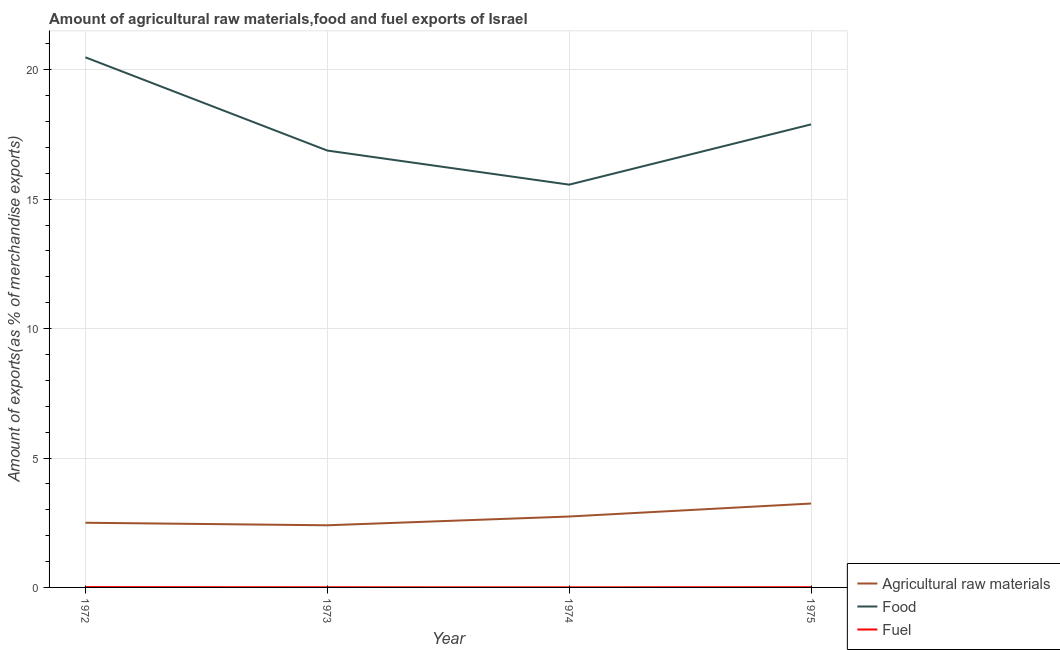Does the line corresponding to percentage of fuel exports intersect with the line corresponding to percentage of raw materials exports?
Offer a very short reply. No. Is the number of lines equal to the number of legend labels?
Your response must be concise. Yes. What is the percentage of fuel exports in 1973?
Ensure brevity in your answer.  0.01. Across all years, what is the maximum percentage of fuel exports?
Give a very brief answer. 0.01. Across all years, what is the minimum percentage of fuel exports?
Keep it short and to the point. 0. In which year was the percentage of fuel exports maximum?
Make the answer very short. 1972. What is the total percentage of food exports in the graph?
Your answer should be compact. 70.81. What is the difference between the percentage of fuel exports in 1972 and that in 1973?
Make the answer very short. 0.01. What is the difference between the percentage of fuel exports in 1974 and the percentage of food exports in 1972?
Ensure brevity in your answer.  -20.48. What is the average percentage of fuel exports per year?
Your answer should be very brief. 0.01. In the year 1973, what is the difference between the percentage of raw materials exports and percentage of fuel exports?
Offer a terse response. 2.39. In how many years, is the percentage of food exports greater than 5 %?
Your response must be concise. 4. What is the ratio of the percentage of fuel exports in 1972 to that in 1973?
Provide a short and direct response. 2.1. What is the difference between the highest and the second highest percentage of fuel exports?
Ensure brevity in your answer.  0. What is the difference between the highest and the lowest percentage of food exports?
Keep it short and to the point. 4.92. Is the percentage of fuel exports strictly greater than the percentage of raw materials exports over the years?
Provide a short and direct response. No. How many lines are there?
Make the answer very short. 3. How many years are there in the graph?
Make the answer very short. 4. What is the difference between two consecutive major ticks on the Y-axis?
Your answer should be very brief. 5. Are the values on the major ticks of Y-axis written in scientific E-notation?
Ensure brevity in your answer.  No. Does the graph contain grids?
Make the answer very short. Yes. How are the legend labels stacked?
Your answer should be very brief. Vertical. What is the title of the graph?
Your answer should be compact. Amount of agricultural raw materials,food and fuel exports of Israel. What is the label or title of the X-axis?
Your answer should be compact. Year. What is the label or title of the Y-axis?
Your response must be concise. Amount of exports(as % of merchandise exports). What is the Amount of exports(as % of merchandise exports) of Agricultural raw materials in 1972?
Your answer should be compact. 2.5. What is the Amount of exports(as % of merchandise exports) in Food in 1972?
Provide a succinct answer. 20.48. What is the Amount of exports(as % of merchandise exports) of Fuel in 1972?
Give a very brief answer. 0.01. What is the Amount of exports(as % of merchandise exports) of Agricultural raw materials in 1973?
Offer a very short reply. 2.4. What is the Amount of exports(as % of merchandise exports) of Food in 1973?
Your answer should be very brief. 16.88. What is the Amount of exports(as % of merchandise exports) in Fuel in 1973?
Your answer should be very brief. 0.01. What is the Amount of exports(as % of merchandise exports) of Agricultural raw materials in 1974?
Your response must be concise. 2.74. What is the Amount of exports(as % of merchandise exports) in Food in 1974?
Make the answer very short. 15.56. What is the Amount of exports(as % of merchandise exports) of Fuel in 1974?
Provide a succinct answer. 0. What is the Amount of exports(as % of merchandise exports) in Agricultural raw materials in 1975?
Your answer should be compact. 3.24. What is the Amount of exports(as % of merchandise exports) in Food in 1975?
Provide a short and direct response. 17.89. What is the Amount of exports(as % of merchandise exports) in Fuel in 1975?
Ensure brevity in your answer.  0.01. Across all years, what is the maximum Amount of exports(as % of merchandise exports) in Agricultural raw materials?
Give a very brief answer. 3.24. Across all years, what is the maximum Amount of exports(as % of merchandise exports) in Food?
Provide a succinct answer. 20.48. Across all years, what is the maximum Amount of exports(as % of merchandise exports) in Fuel?
Provide a succinct answer. 0.01. Across all years, what is the minimum Amount of exports(as % of merchandise exports) in Agricultural raw materials?
Keep it short and to the point. 2.4. Across all years, what is the minimum Amount of exports(as % of merchandise exports) in Food?
Offer a terse response. 15.56. Across all years, what is the minimum Amount of exports(as % of merchandise exports) of Fuel?
Your response must be concise. 0. What is the total Amount of exports(as % of merchandise exports) of Agricultural raw materials in the graph?
Provide a succinct answer. 10.88. What is the total Amount of exports(as % of merchandise exports) of Food in the graph?
Your answer should be very brief. 70.81. What is the total Amount of exports(as % of merchandise exports) of Fuel in the graph?
Your answer should be very brief. 0.04. What is the difference between the Amount of exports(as % of merchandise exports) of Agricultural raw materials in 1972 and that in 1973?
Ensure brevity in your answer.  0.1. What is the difference between the Amount of exports(as % of merchandise exports) in Food in 1972 and that in 1973?
Make the answer very short. 3.6. What is the difference between the Amount of exports(as % of merchandise exports) of Fuel in 1972 and that in 1973?
Offer a terse response. 0.01. What is the difference between the Amount of exports(as % of merchandise exports) in Agricultural raw materials in 1972 and that in 1974?
Ensure brevity in your answer.  -0.24. What is the difference between the Amount of exports(as % of merchandise exports) of Food in 1972 and that in 1974?
Your answer should be very brief. 4.92. What is the difference between the Amount of exports(as % of merchandise exports) of Fuel in 1972 and that in 1974?
Your answer should be very brief. 0.01. What is the difference between the Amount of exports(as % of merchandise exports) of Agricultural raw materials in 1972 and that in 1975?
Your answer should be very brief. -0.74. What is the difference between the Amount of exports(as % of merchandise exports) of Food in 1972 and that in 1975?
Offer a terse response. 2.59. What is the difference between the Amount of exports(as % of merchandise exports) in Fuel in 1972 and that in 1975?
Offer a very short reply. 0. What is the difference between the Amount of exports(as % of merchandise exports) in Agricultural raw materials in 1973 and that in 1974?
Your answer should be very brief. -0.34. What is the difference between the Amount of exports(as % of merchandise exports) in Food in 1973 and that in 1974?
Ensure brevity in your answer.  1.32. What is the difference between the Amount of exports(as % of merchandise exports) in Fuel in 1973 and that in 1974?
Keep it short and to the point. 0. What is the difference between the Amount of exports(as % of merchandise exports) in Agricultural raw materials in 1973 and that in 1975?
Keep it short and to the point. -0.84. What is the difference between the Amount of exports(as % of merchandise exports) in Food in 1973 and that in 1975?
Offer a terse response. -1.01. What is the difference between the Amount of exports(as % of merchandise exports) in Fuel in 1973 and that in 1975?
Provide a short and direct response. -0. What is the difference between the Amount of exports(as % of merchandise exports) in Agricultural raw materials in 1974 and that in 1975?
Provide a short and direct response. -0.5. What is the difference between the Amount of exports(as % of merchandise exports) in Food in 1974 and that in 1975?
Your answer should be compact. -2.33. What is the difference between the Amount of exports(as % of merchandise exports) in Fuel in 1974 and that in 1975?
Offer a very short reply. -0. What is the difference between the Amount of exports(as % of merchandise exports) of Agricultural raw materials in 1972 and the Amount of exports(as % of merchandise exports) of Food in 1973?
Give a very brief answer. -14.38. What is the difference between the Amount of exports(as % of merchandise exports) in Agricultural raw materials in 1972 and the Amount of exports(as % of merchandise exports) in Fuel in 1973?
Offer a very short reply. 2.49. What is the difference between the Amount of exports(as % of merchandise exports) of Food in 1972 and the Amount of exports(as % of merchandise exports) of Fuel in 1973?
Your answer should be compact. 20.48. What is the difference between the Amount of exports(as % of merchandise exports) of Agricultural raw materials in 1972 and the Amount of exports(as % of merchandise exports) of Food in 1974?
Offer a terse response. -13.06. What is the difference between the Amount of exports(as % of merchandise exports) in Agricultural raw materials in 1972 and the Amount of exports(as % of merchandise exports) in Fuel in 1974?
Keep it short and to the point. 2.49. What is the difference between the Amount of exports(as % of merchandise exports) in Food in 1972 and the Amount of exports(as % of merchandise exports) in Fuel in 1974?
Make the answer very short. 20.48. What is the difference between the Amount of exports(as % of merchandise exports) in Agricultural raw materials in 1972 and the Amount of exports(as % of merchandise exports) in Food in 1975?
Your answer should be very brief. -15.39. What is the difference between the Amount of exports(as % of merchandise exports) of Agricultural raw materials in 1972 and the Amount of exports(as % of merchandise exports) of Fuel in 1975?
Offer a terse response. 2.49. What is the difference between the Amount of exports(as % of merchandise exports) of Food in 1972 and the Amount of exports(as % of merchandise exports) of Fuel in 1975?
Offer a terse response. 20.47. What is the difference between the Amount of exports(as % of merchandise exports) in Agricultural raw materials in 1973 and the Amount of exports(as % of merchandise exports) in Food in 1974?
Offer a terse response. -13.16. What is the difference between the Amount of exports(as % of merchandise exports) in Agricultural raw materials in 1973 and the Amount of exports(as % of merchandise exports) in Fuel in 1974?
Keep it short and to the point. 2.4. What is the difference between the Amount of exports(as % of merchandise exports) in Food in 1973 and the Amount of exports(as % of merchandise exports) in Fuel in 1974?
Ensure brevity in your answer.  16.87. What is the difference between the Amount of exports(as % of merchandise exports) of Agricultural raw materials in 1973 and the Amount of exports(as % of merchandise exports) of Food in 1975?
Provide a short and direct response. -15.49. What is the difference between the Amount of exports(as % of merchandise exports) in Agricultural raw materials in 1973 and the Amount of exports(as % of merchandise exports) in Fuel in 1975?
Provide a succinct answer. 2.39. What is the difference between the Amount of exports(as % of merchandise exports) of Food in 1973 and the Amount of exports(as % of merchandise exports) of Fuel in 1975?
Ensure brevity in your answer.  16.87. What is the difference between the Amount of exports(as % of merchandise exports) of Agricultural raw materials in 1974 and the Amount of exports(as % of merchandise exports) of Food in 1975?
Make the answer very short. -15.15. What is the difference between the Amount of exports(as % of merchandise exports) of Agricultural raw materials in 1974 and the Amount of exports(as % of merchandise exports) of Fuel in 1975?
Offer a very short reply. 2.73. What is the difference between the Amount of exports(as % of merchandise exports) in Food in 1974 and the Amount of exports(as % of merchandise exports) in Fuel in 1975?
Keep it short and to the point. 15.55. What is the average Amount of exports(as % of merchandise exports) of Agricultural raw materials per year?
Your answer should be compact. 2.72. What is the average Amount of exports(as % of merchandise exports) in Food per year?
Keep it short and to the point. 17.7. What is the average Amount of exports(as % of merchandise exports) of Fuel per year?
Your answer should be compact. 0.01. In the year 1972, what is the difference between the Amount of exports(as % of merchandise exports) in Agricultural raw materials and Amount of exports(as % of merchandise exports) in Food?
Provide a short and direct response. -17.98. In the year 1972, what is the difference between the Amount of exports(as % of merchandise exports) of Agricultural raw materials and Amount of exports(as % of merchandise exports) of Fuel?
Your answer should be compact. 2.49. In the year 1972, what is the difference between the Amount of exports(as % of merchandise exports) in Food and Amount of exports(as % of merchandise exports) in Fuel?
Keep it short and to the point. 20.47. In the year 1973, what is the difference between the Amount of exports(as % of merchandise exports) of Agricultural raw materials and Amount of exports(as % of merchandise exports) of Food?
Keep it short and to the point. -14.48. In the year 1973, what is the difference between the Amount of exports(as % of merchandise exports) in Agricultural raw materials and Amount of exports(as % of merchandise exports) in Fuel?
Make the answer very short. 2.39. In the year 1973, what is the difference between the Amount of exports(as % of merchandise exports) of Food and Amount of exports(as % of merchandise exports) of Fuel?
Offer a terse response. 16.87. In the year 1974, what is the difference between the Amount of exports(as % of merchandise exports) in Agricultural raw materials and Amount of exports(as % of merchandise exports) in Food?
Give a very brief answer. -12.82. In the year 1974, what is the difference between the Amount of exports(as % of merchandise exports) in Agricultural raw materials and Amount of exports(as % of merchandise exports) in Fuel?
Your response must be concise. 2.74. In the year 1974, what is the difference between the Amount of exports(as % of merchandise exports) in Food and Amount of exports(as % of merchandise exports) in Fuel?
Your answer should be very brief. 15.56. In the year 1975, what is the difference between the Amount of exports(as % of merchandise exports) of Agricultural raw materials and Amount of exports(as % of merchandise exports) of Food?
Keep it short and to the point. -14.65. In the year 1975, what is the difference between the Amount of exports(as % of merchandise exports) of Agricultural raw materials and Amount of exports(as % of merchandise exports) of Fuel?
Your response must be concise. 3.23. In the year 1975, what is the difference between the Amount of exports(as % of merchandise exports) of Food and Amount of exports(as % of merchandise exports) of Fuel?
Offer a terse response. 17.88. What is the ratio of the Amount of exports(as % of merchandise exports) of Agricultural raw materials in 1972 to that in 1973?
Your answer should be very brief. 1.04. What is the ratio of the Amount of exports(as % of merchandise exports) of Food in 1972 to that in 1973?
Offer a very short reply. 1.21. What is the ratio of the Amount of exports(as % of merchandise exports) in Fuel in 1972 to that in 1973?
Make the answer very short. 2.1. What is the ratio of the Amount of exports(as % of merchandise exports) of Agricultural raw materials in 1972 to that in 1974?
Make the answer very short. 0.91. What is the ratio of the Amount of exports(as % of merchandise exports) in Food in 1972 to that in 1974?
Your response must be concise. 1.32. What is the ratio of the Amount of exports(as % of merchandise exports) in Fuel in 1972 to that in 1974?
Your answer should be very brief. 2.83. What is the ratio of the Amount of exports(as % of merchandise exports) of Agricultural raw materials in 1972 to that in 1975?
Ensure brevity in your answer.  0.77. What is the ratio of the Amount of exports(as % of merchandise exports) of Food in 1972 to that in 1975?
Provide a succinct answer. 1.14. What is the ratio of the Amount of exports(as % of merchandise exports) in Fuel in 1972 to that in 1975?
Keep it short and to the point. 1.44. What is the ratio of the Amount of exports(as % of merchandise exports) in Agricultural raw materials in 1973 to that in 1974?
Provide a short and direct response. 0.88. What is the ratio of the Amount of exports(as % of merchandise exports) of Food in 1973 to that in 1974?
Your response must be concise. 1.08. What is the ratio of the Amount of exports(as % of merchandise exports) in Fuel in 1973 to that in 1974?
Keep it short and to the point. 1.35. What is the ratio of the Amount of exports(as % of merchandise exports) in Agricultural raw materials in 1973 to that in 1975?
Keep it short and to the point. 0.74. What is the ratio of the Amount of exports(as % of merchandise exports) in Food in 1973 to that in 1975?
Your response must be concise. 0.94. What is the ratio of the Amount of exports(as % of merchandise exports) in Fuel in 1973 to that in 1975?
Ensure brevity in your answer.  0.69. What is the ratio of the Amount of exports(as % of merchandise exports) of Agricultural raw materials in 1974 to that in 1975?
Offer a very short reply. 0.85. What is the ratio of the Amount of exports(as % of merchandise exports) of Food in 1974 to that in 1975?
Offer a very short reply. 0.87. What is the ratio of the Amount of exports(as % of merchandise exports) of Fuel in 1974 to that in 1975?
Make the answer very short. 0.51. What is the difference between the highest and the second highest Amount of exports(as % of merchandise exports) in Agricultural raw materials?
Keep it short and to the point. 0.5. What is the difference between the highest and the second highest Amount of exports(as % of merchandise exports) of Food?
Offer a very short reply. 2.59. What is the difference between the highest and the second highest Amount of exports(as % of merchandise exports) in Fuel?
Provide a succinct answer. 0. What is the difference between the highest and the lowest Amount of exports(as % of merchandise exports) in Agricultural raw materials?
Your answer should be very brief. 0.84. What is the difference between the highest and the lowest Amount of exports(as % of merchandise exports) in Food?
Your answer should be very brief. 4.92. What is the difference between the highest and the lowest Amount of exports(as % of merchandise exports) in Fuel?
Offer a very short reply. 0.01. 